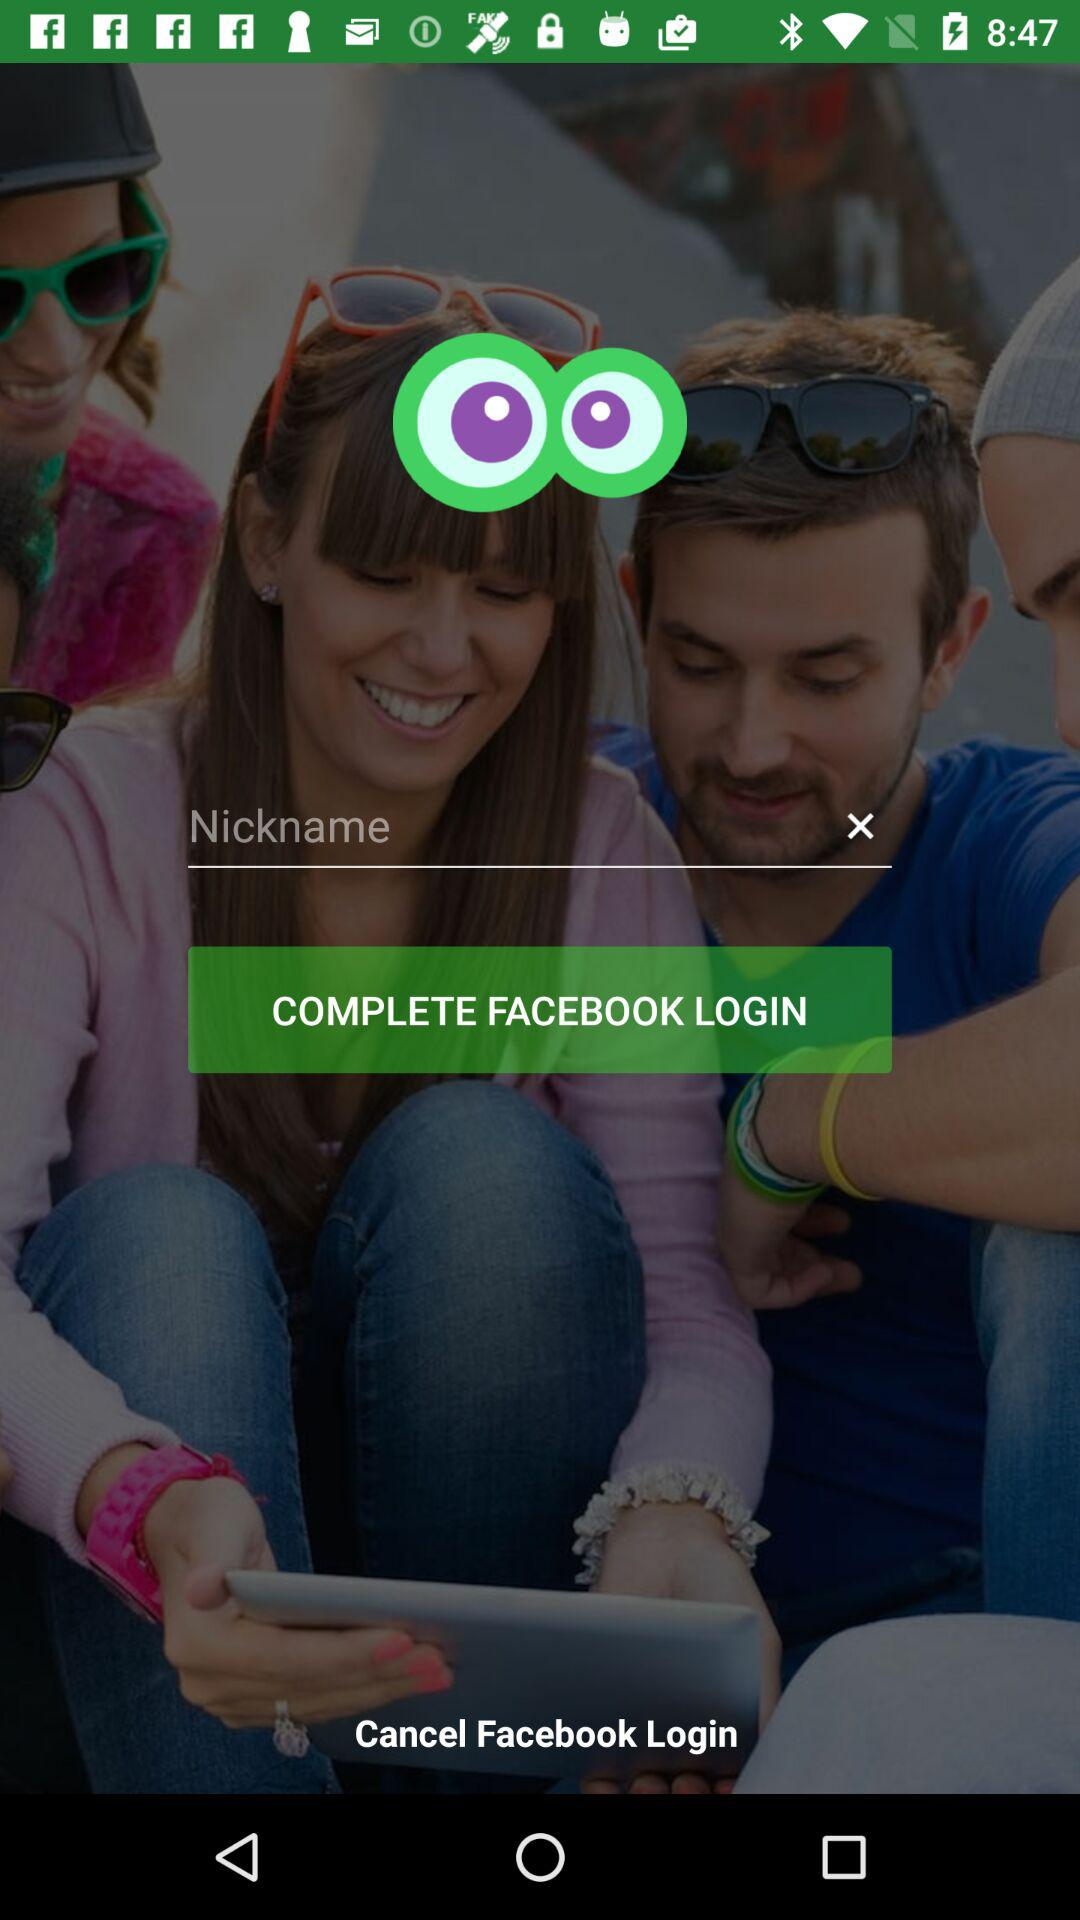Through what application can we log in? You can log in through "FACEBOOK". 